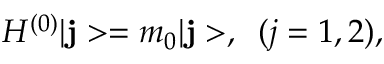Convert formula to latex. <formula><loc_0><loc_0><loc_500><loc_500>H ^ { ( 0 ) } | { j } > = m _ { 0 } | { j } > , \, ( j = 1 , 2 ) ,</formula> 